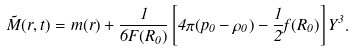Convert formula to latex. <formula><loc_0><loc_0><loc_500><loc_500>\tilde { M } ( r , t ) = m ( r ) + \frac { 1 } { 6 F ( R _ { 0 } ) } \left [ 4 \pi ( p _ { 0 } - \rho _ { 0 } ) - \frac { 1 } { 2 } f ( R _ { 0 } ) \right ] Y ^ { 3 } .</formula> 